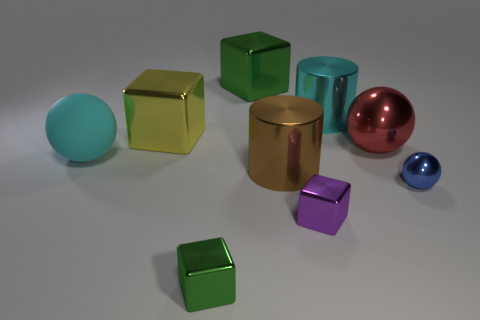What number of cylinders are the same color as the large matte thing?
Provide a short and direct response. 1. There is a shiny ball that is on the left side of the tiny blue thing; is its color the same as the matte sphere?
Keep it short and to the point. No. What size is the other thing that is the same color as the big rubber thing?
Your answer should be very brief. Large. What material is the large object left of the large metal block in front of the large shiny cube to the right of the large yellow metal block?
Provide a short and direct response. Rubber. What material is the object that is the same color as the rubber ball?
Make the answer very short. Metal. Does the large object to the left of the big yellow block have the same color as the big cylinder behind the brown object?
Ensure brevity in your answer.  Yes. What is the shape of the blue metallic object in front of the ball on the left side of the cube that is in front of the tiny purple object?
Make the answer very short. Sphere. What shape is the big metal thing that is both behind the large yellow shiny block and to the right of the purple metallic object?
Make the answer very short. Cylinder. There is a big cylinder right of the tiny cube on the right side of the big brown cylinder; what number of tiny purple blocks are left of it?
Provide a succinct answer. 1. There is another shiny thing that is the same shape as the blue shiny thing; what size is it?
Ensure brevity in your answer.  Large. 